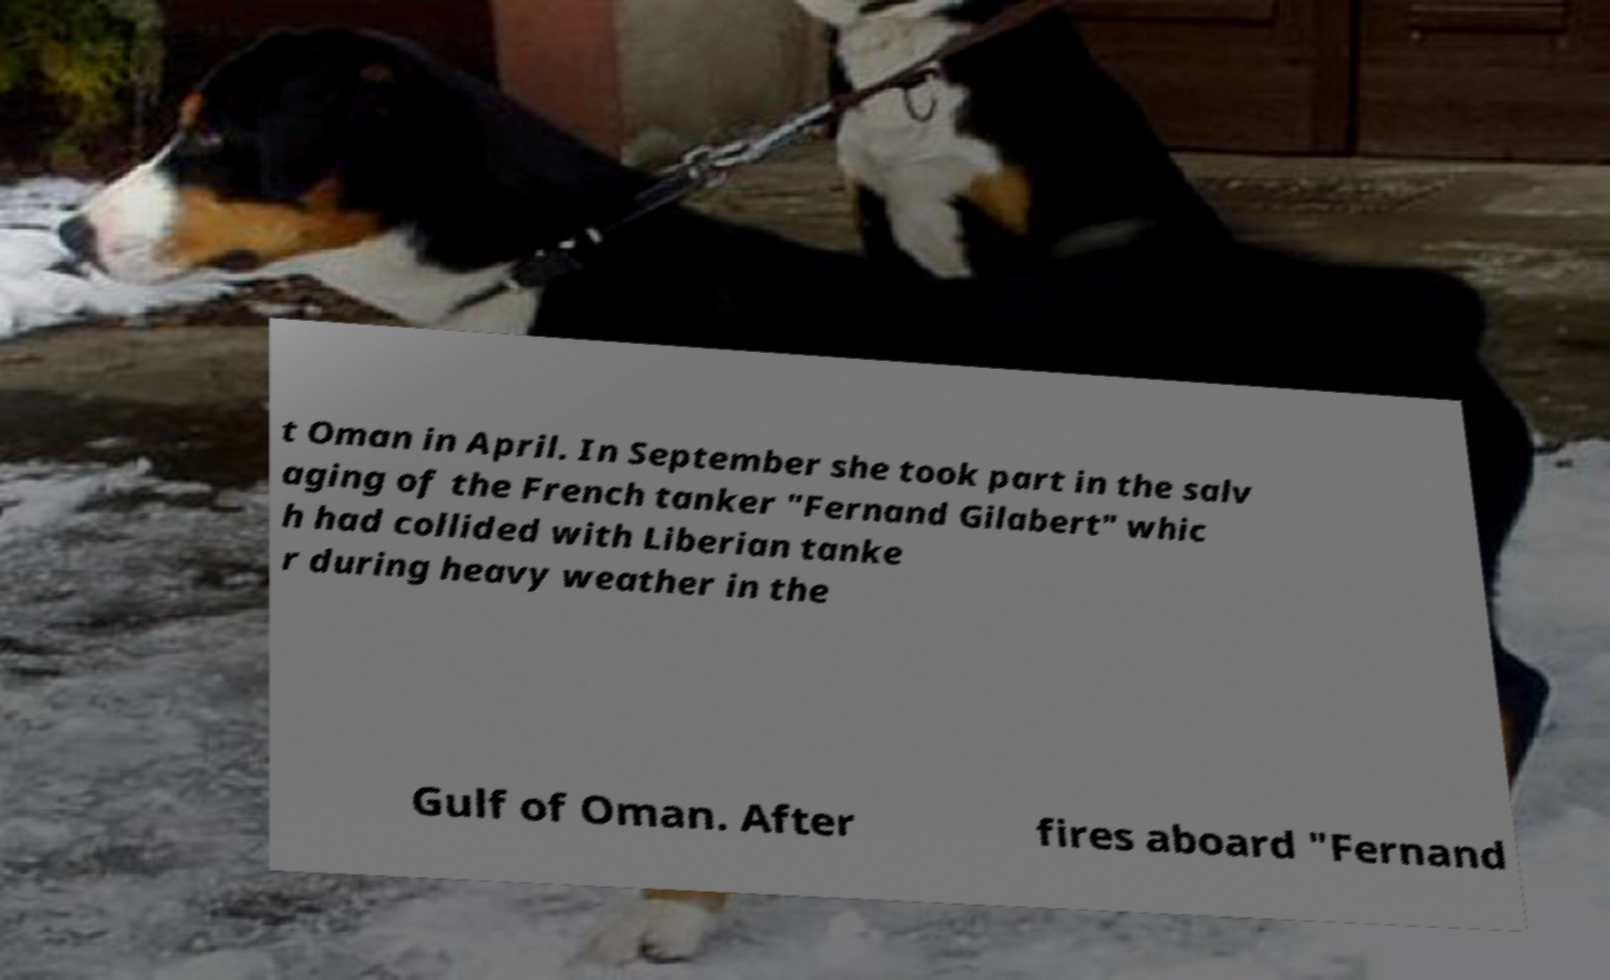I need the written content from this picture converted into text. Can you do that? t Oman in April. In September she took part in the salv aging of the French tanker "Fernand Gilabert" whic h had collided with Liberian tanke r during heavy weather in the Gulf of Oman. After fires aboard "Fernand 